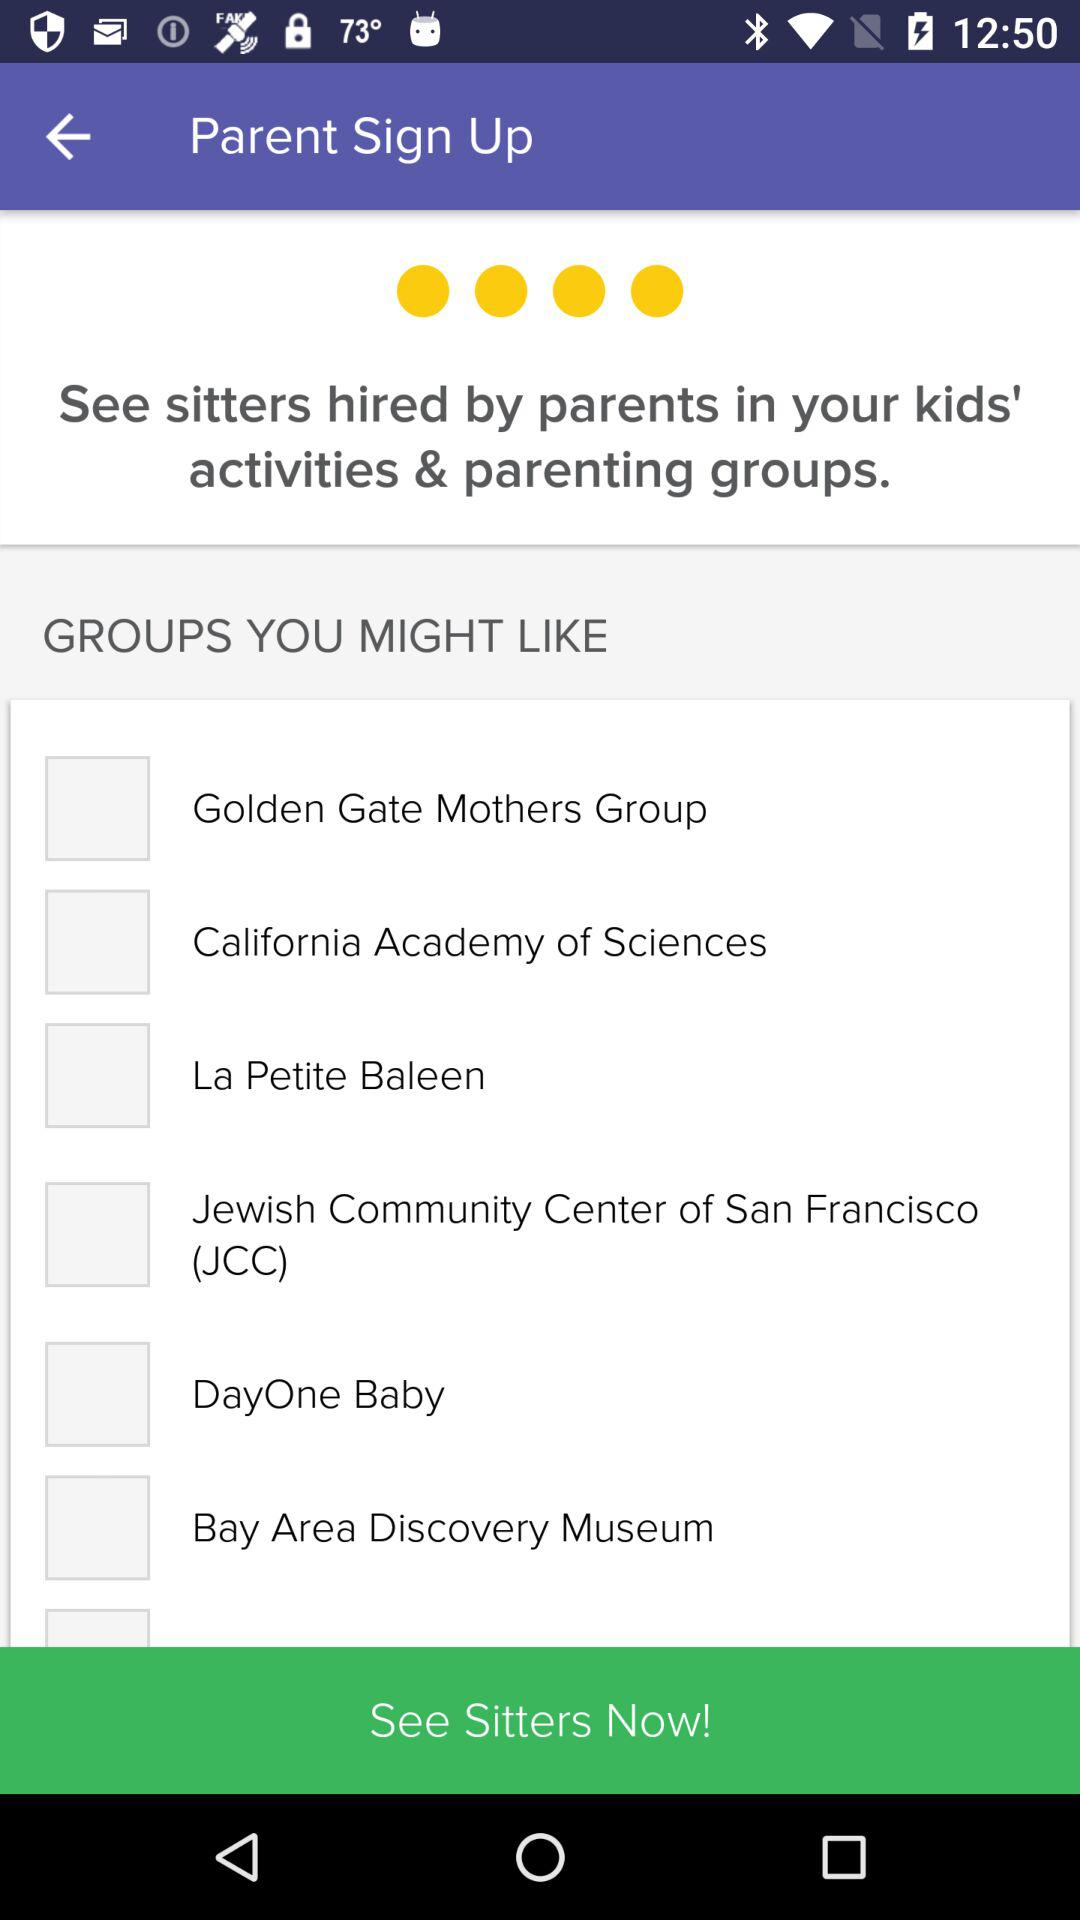What is the status of "DayOne Baby"? The status is "off". 